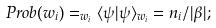<formula> <loc_0><loc_0><loc_500><loc_500>P r o b ( w _ { i } ) = _ { w _ { i } } \langle \psi | \psi \rangle _ { w _ { i } } = n _ { i } / | \beta | ;</formula> 